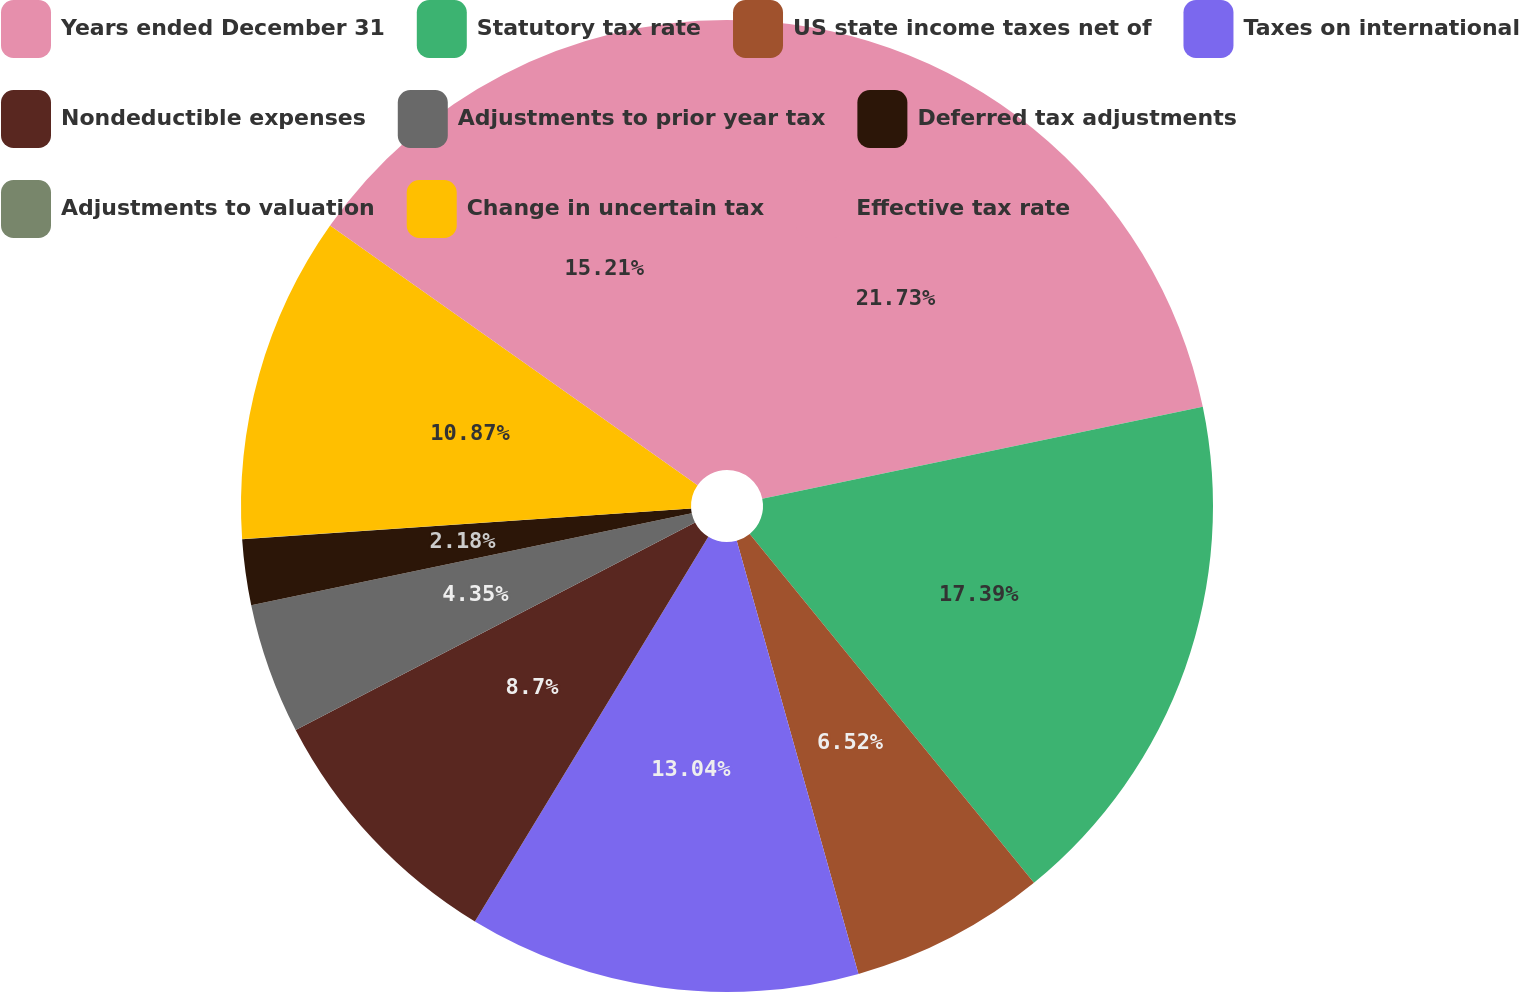Convert chart. <chart><loc_0><loc_0><loc_500><loc_500><pie_chart><fcel>Years ended December 31<fcel>Statutory tax rate<fcel>US state income taxes net of<fcel>Taxes on international<fcel>Nondeductible expenses<fcel>Adjustments to prior year tax<fcel>Deferred tax adjustments<fcel>Adjustments to valuation<fcel>Change in uncertain tax<fcel>Effective tax rate<nl><fcel>21.73%<fcel>17.39%<fcel>6.52%<fcel>13.04%<fcel>8.7%<fcel>4.35%<fcel>2.18%<fcel>0.01%<fcel>10.87%<fcel>15.21%<nl></chart> 